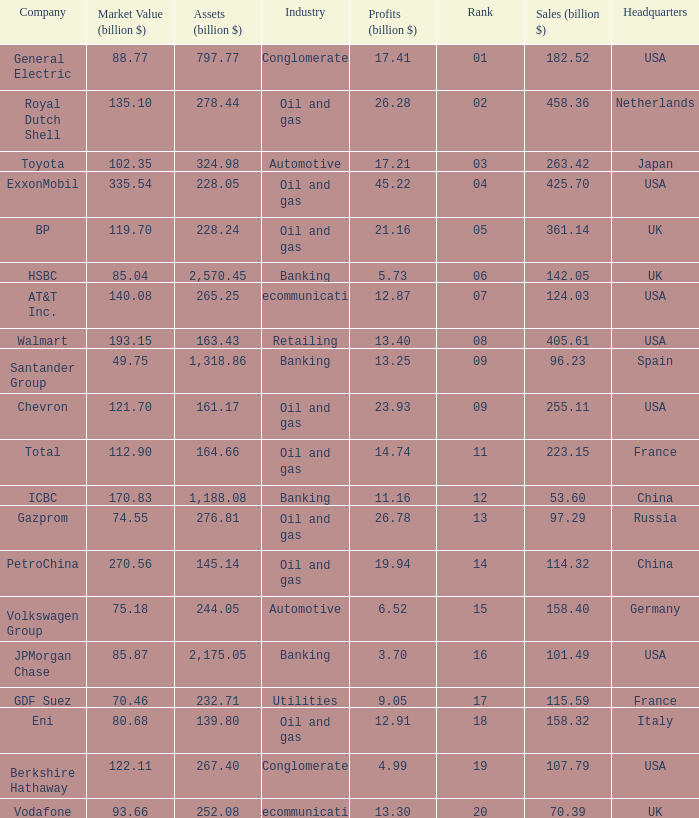Name the lowest Profits (billion $) which has a Sales (billion $) of 425.7, and a Rank larger than 4? None. 